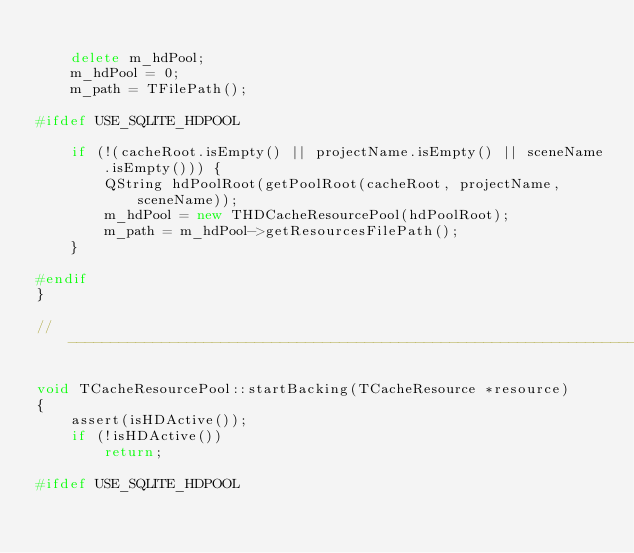Convert code to text. <code><loc_0><loc_0><loc_500><loc_500><_C++_>
	delete m_hdPool;
	m_hdPool = 0;
	m_path = TFilePath();

#ifdef USE_SQLITE_HDPOOL

	if (!(cacheRoot.isEmpty() || projectName.isEmpty() || sceneName.isEmpty())) {
		QString hdPoolRoot(getPoolRoot(cacheRoot, projectName, sceneName));
		m_hdPool = new THDCacheResourcePool(hdPoolRoot);
		m_path = m_hdPool->getResourcesFilePath();
	}

#endif
}

//-----------------------------------------------------------------------------------

void TCacheResourcePool::startBacking(TCacheResource *resource)
{
	assert(isHDActive());
	if (!isHDActive())
		return;

#ifdef USE_SQLITE_HDPOOL
</code> 